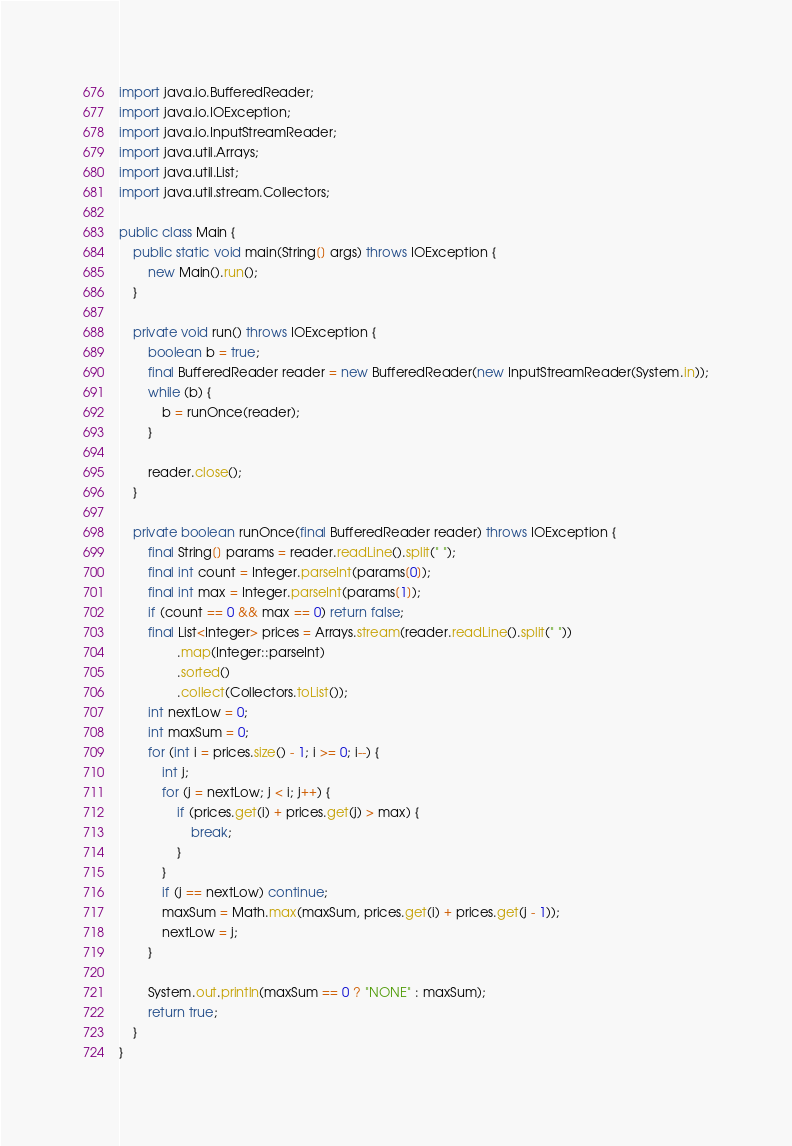Convert code to text. <code><loc_0><loc_0><loc_500><loc_500><_Java_>
import java.io.BufferedReader;
import java.io.IOException;
import java.io.InputStreamReader;
import java.util.Arrays;
import java.util.List;
import java.util.stream.Collectors;

public class Main {
    public static void main(String[] args) throws IOException {
        new Main().run();
    }

    private void run() throws IOException {
        boolean b = true;
        final BufferedReader reader = new BufferedReader(new InputStreamReader(System.in));
        while (b) {
            b = runOnce(reader);
        }

        reader.close();
    }

    private boolean runOnce(final BufferedReader reader) throws IOException {
        final String[] params = reader.readLine().split(" ");
        final int count = Integer.parseInt(params[0]);
        final int max = Integer.parseInt(params[1]);
        if (count == 0 && max == 0) return false;
        final List<Integer> prices = Arrays.stream(reader.readLine().split(" "))
                .map(Integer::parseInt)
                .sorted()
                .collect(Collectors.toList());
        int nextLow = 0;
        int maxSum = 0;
        for (int i = prices.size() - 1; i >= 0; i--) {
            int j;
            for (j = nextLow; j < i; j++) {
                if (prices.get(i) + prices.get(j) > max) {
                    break;
                }
            }
            if (j == nextLow) continue;
            maxSum = Math.max(maxSum, prices.get(i) + prices.get(j - 1));
            nextLow = j;
        }

        System.out.println(maxSum == 0 ? "NONE" : maxSum);
        return true;
    }
}</code> 